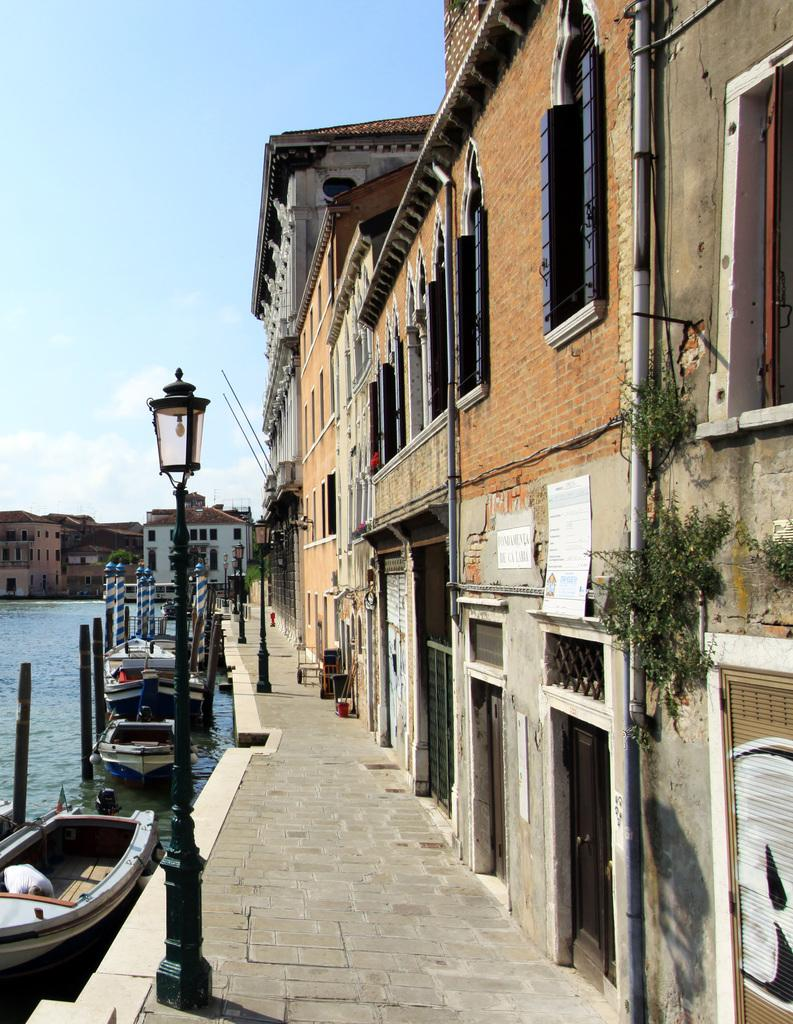What type of structures can be seen in the image? There are buildings in the image. What is on the water in the image? There are boats on the water. What are the poles used for in the image? The purpose of the poles is not specified, but they are visible in the image. What are the lights associated with in the image? The lights are associated with the buildings or other structures in the image. What are the pipes used for in the image? The purpose of the pipes is not specified, but they are visible in the image. What else can be seen in the image besides the mentioned objects? There are other unspecified objects in the image. What is visible in the background of the image? The sky is visible in the background of the image. Where is the lunchroom located in the image? There is no mention of a lunchroom in the image, so its location cannot be determined. What is the skill level of the beginner in the image? There is no person or activity related to a beginner in the image, so their skill level cannot be determined. 